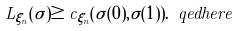<formula> <loc_0><loc_0><loc_500><loc_500>L _ { \xi _ { n } } ( \sigma ) \geq c _ { \xi _ { n } } ( \sigma ( 0 ) , \sigma ( 1 ) ) . \ q e d h e r e</formula> 